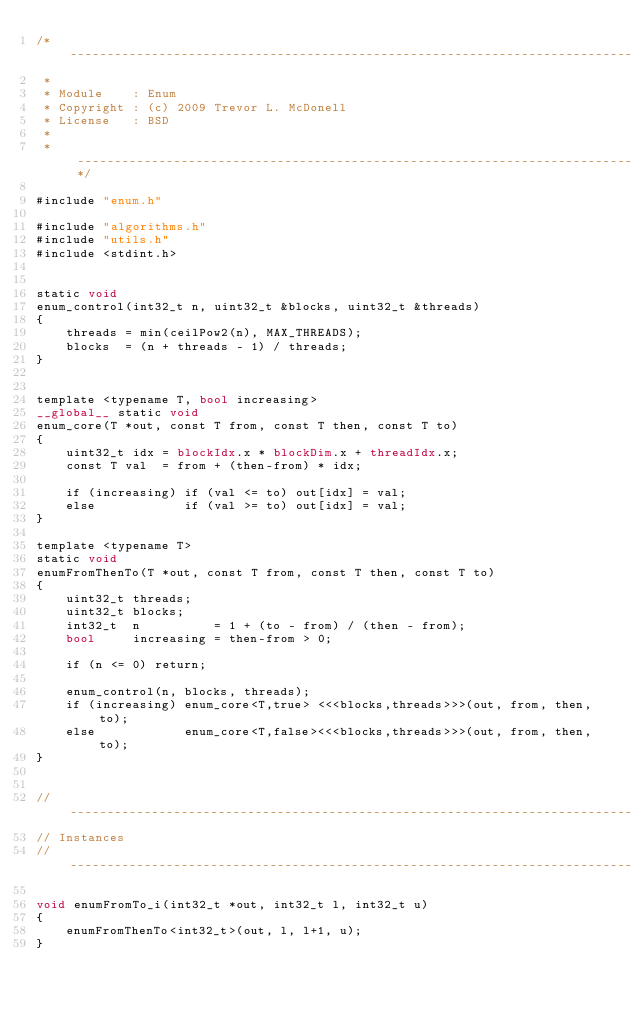<code> <loc_0><loc_0><loc_500><loc_500><_Cuda_>/* -----------------------------------------------------------------------------
 *
 * Module    : Enum
 * Copyright : (c) 2009 Trevor L. McDonell
 * License   : BSD
 *
 * ---------------------------------------------------------------------------*/

#include "enum.h"

#include "algorithms.h"
#include "utils.h"
#include <stdint.h>


static void
enum_control(int32_t n, uint32_t &blocks, uint32_t &threads)
{
    threads = min(ceilPow2(n), MAX_THREADS);
    blocks  = (n + threads - 1) / threads;
}


template <typename T, bool increasing>
__global__ static void
enum_core(T *out, const T from, const T then, const T to)
{
    uint32_t idx = blockIdx.x * blockDim.x + threadIdx.x;
    const T val  = from + (then-from) * idx;

    if (increasing) if (val <= to) out[idx] = val;
    else            if (val >= to) out[idx] = val;
}

template <typename T>
static void
enumFromThenTo(T *out, const T from, const T then, const T to)
{
    uint32_t threads;
    uint32_t blocks;
    int32_t  n          = 1 + (to - from) / (then - from);
    bool     increasing = then-from > 0;

    if (n <= 0) return;

    enum_control(n, blocks, threads);
    if (increasing) enum_core<T,true> <<<blocks,threads>>>(out, from, then, to);
    else            enum_core<T,false><<<blocks,threads>>>(out, from, then, to);
}


// -----------------------------------------------------------------------------
// Instances
// -----------------------------------------------------------------------------

void enumFromTo_i(int32_t *out, int32_t l, int32_t u)
{
    enumFromThenTo<int32_t>(out, l, l+1, u);
}

</code> 